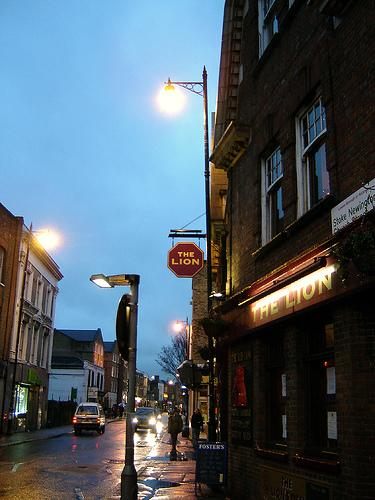Which sign will be easier for someone way down the street to spot? lion 